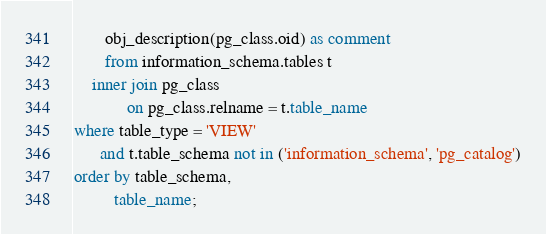Convert code to text. <code><loc_0><loc_0><loc_500><loc_500><_SQL_>       obj_description(pg_class.oid) as comment
       from information_schema.tables t
    inner join pg_class
            on pg_class.relname = t.table_name
where table_type = 'VIEW' 
      and t.table_schema not in ('information_schema', 'pg_catalog')
order by table_schema,
         table_name;</code> 